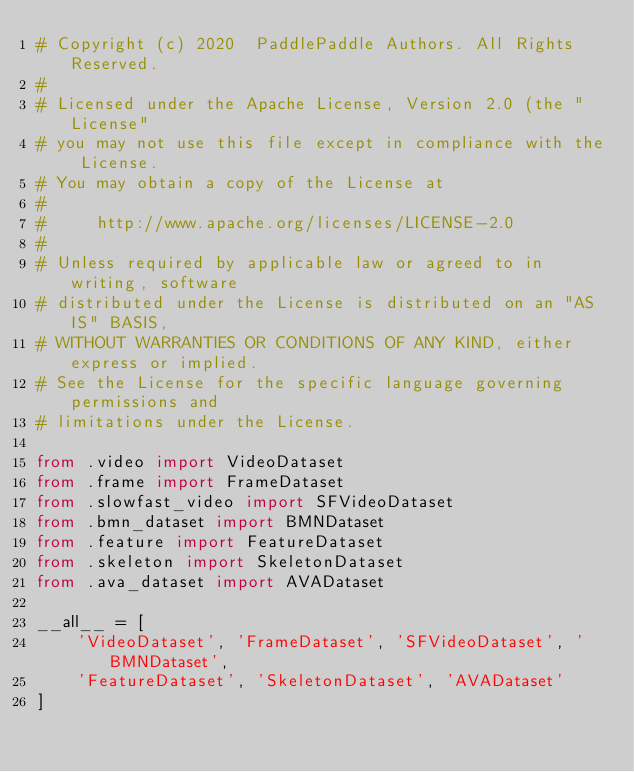<code> <loc_0><loc_0><loc_500><loc_500><_Python_># Copyright (c) 2020  PaddlePaddle Authors. All Rights Reserved.
#
# Licensed under the Apache License, Version 2.0 (the "License"
# you may not use this file except in compliance with the License.
# You may obtain a copy of the License at
#
#     http://www.apache.org/licenses/LICENSE-2.0
#
# Unless required by applicable law or agreed to in writing, software
# distributed under the License is distributed on an "AS IS" BASIS,
# WITHOUT WARRANTIES OR CONDITIONS OF ANY KIND, either express or implied.
# See the License for the specific language governing permissions and
# limitations under the License.

from .video import VideoDataset
from .frame import FrameDataset
from .slowfast_video import SFVideoDataset
from .bmn_dataset import BMNDataset
from .feature import FeatureDataset
from .skeleton import SkeletonDataset
from .ava_dataset import AVADataset

__all__ = [
    'VideoDataset', 'FrameDataset', 'SFVideoDataset', 'BMNDataset',
    'FeatureDataset', 'SkeletonDataset', 'AVADataset'
]
</code> 